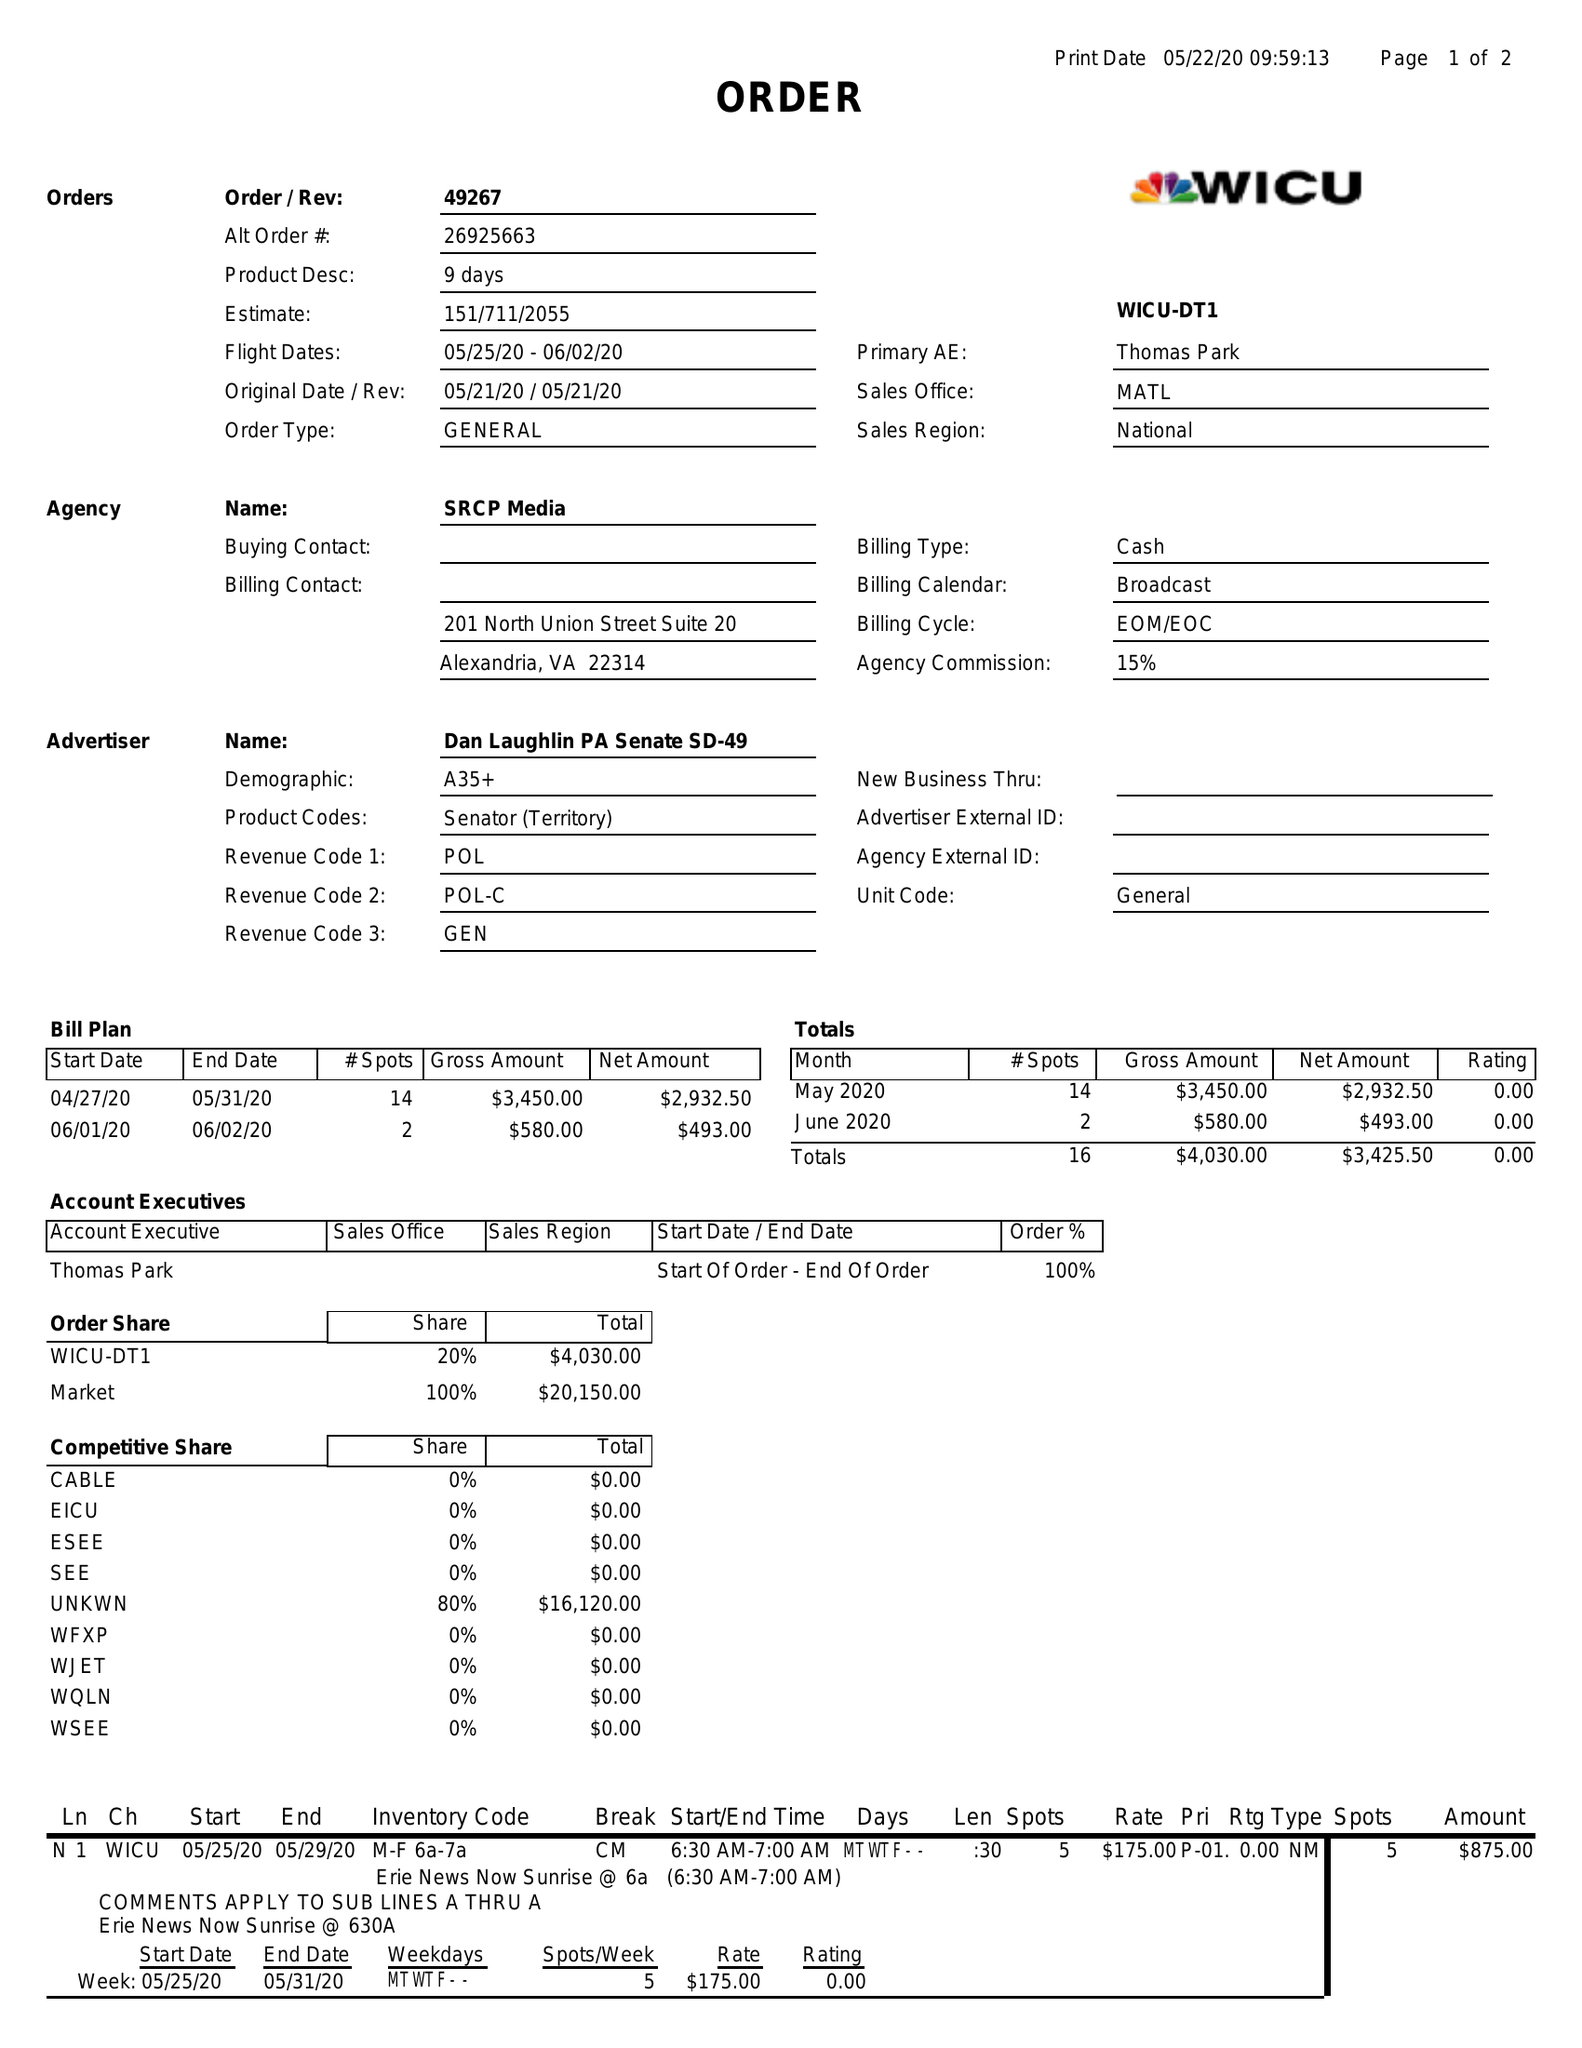What is the value for the contract_num?
Answer the question using a single word or phrase. 49267 